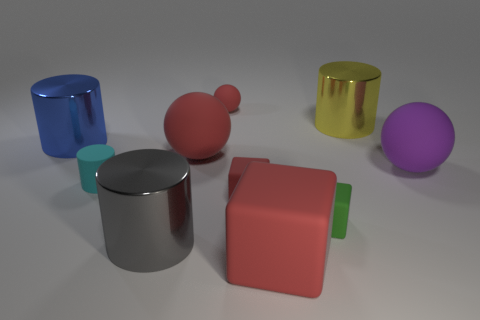Subtract all small blocks. How many blocks are left? 1 Subtract all green blocks. How many red spheres are left? 2 Subtract all blue cylinders. How many cylinders are left? 3 Subtract 2 spheres. How many spheres are left? 1 Add 2 tiny red rubber things. How many tiny red rubber things exist? 4 Subtract 1 green blocks. How many objects are left? 9 Subtract all cylinders. How many objects are left? 6 Subtract all blue blocks. Subtract all cyan spheres. How many blocks are left? 3 Subtract all large cyan cylinders. Subtract all green things. How many objects are left? 9 Add 3 tiny rubber cylinders. How many tiny rubber cylinders are left? 4 